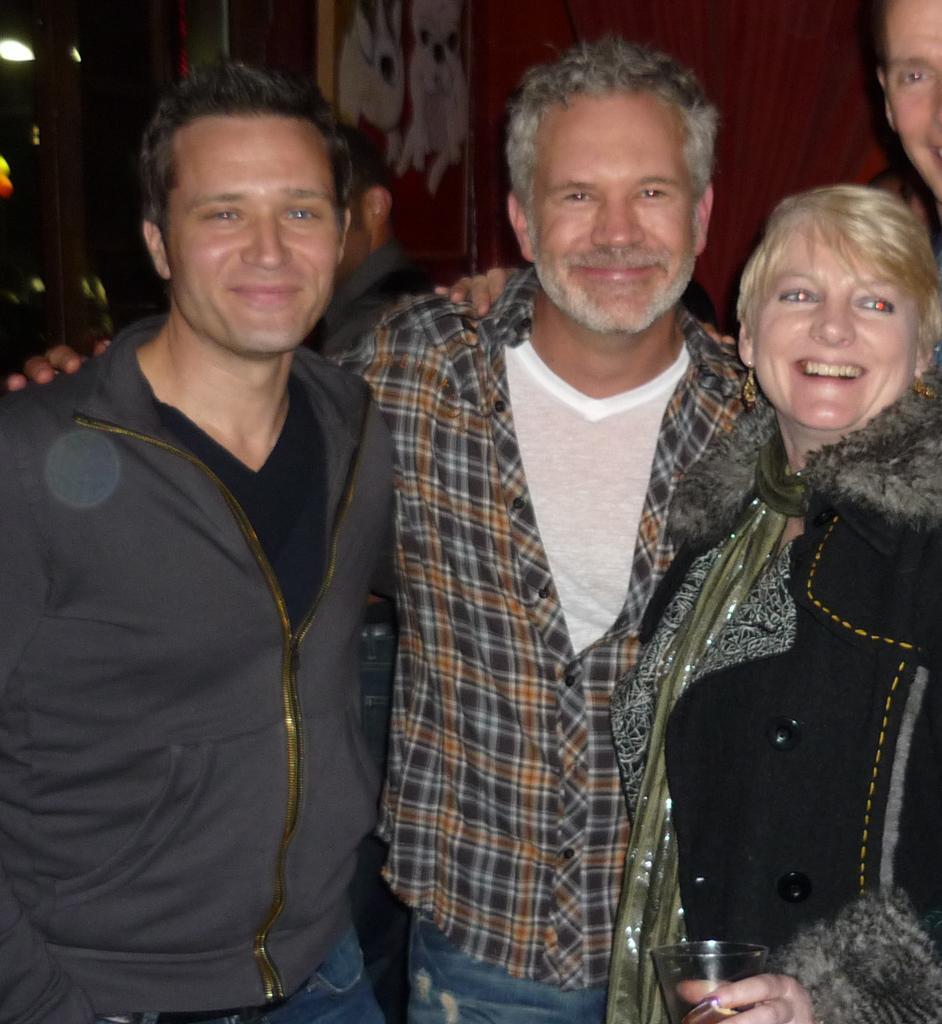Please provide a concise description of this image. In this picture we can see five people, three people are smiling and standing. In the background we can see the wall, lights and it is dark. 